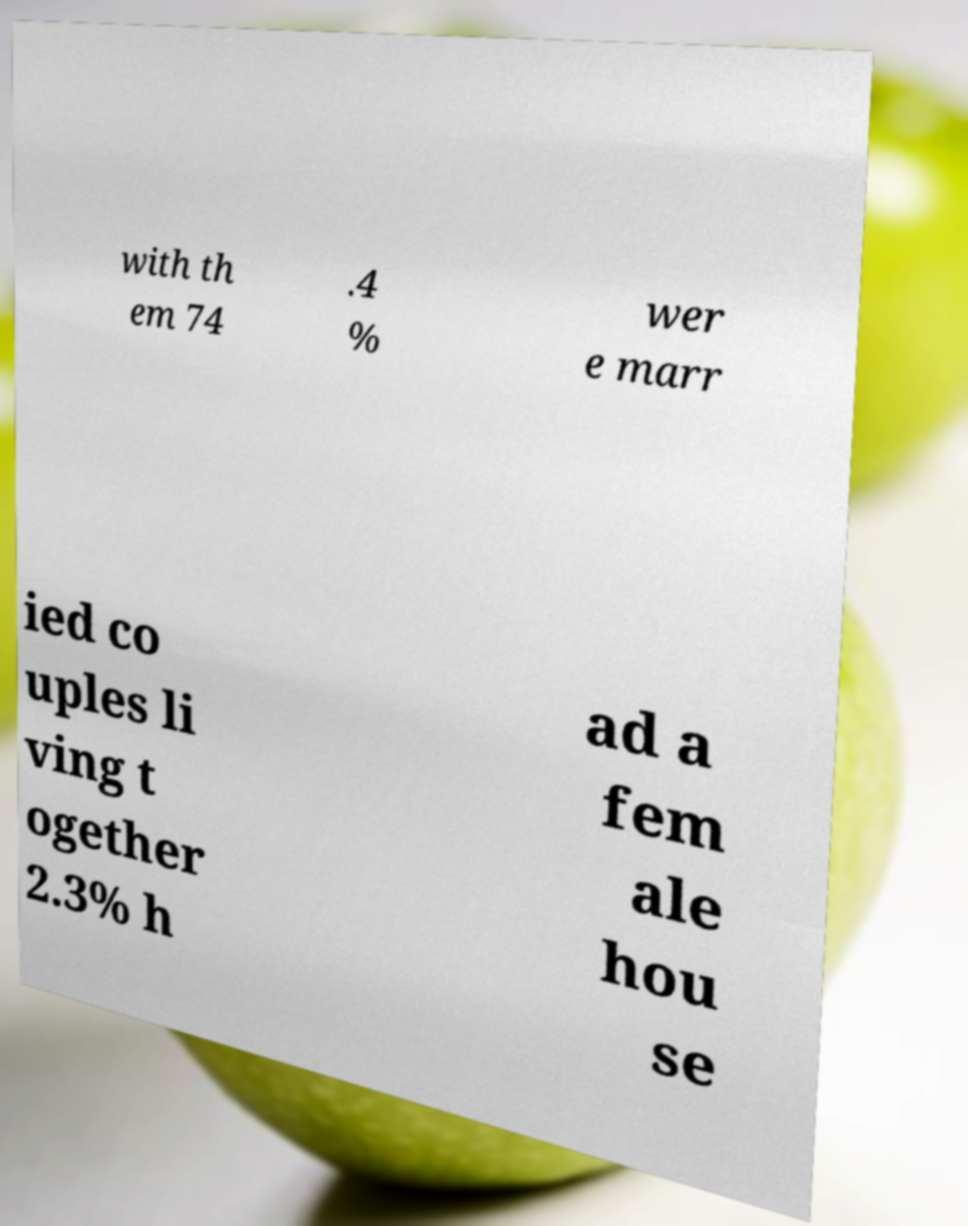What messages or text are displayed in this image? I need them in a readable, typed format. with th em 74 .4 % wer e marr ied co uples li ving t ogether 2.3% h ad a fem ale hou se 